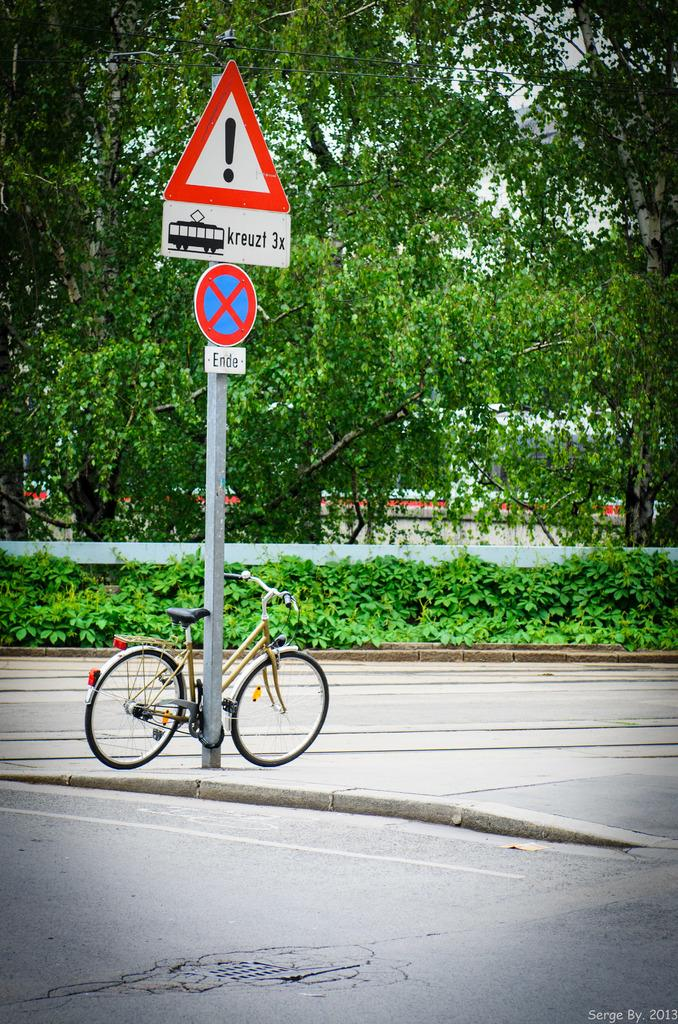Provide a one-sentence caption for the provided image. A bicycle is locked onto a pole with Ende and kruezl 3x on it on the street. 